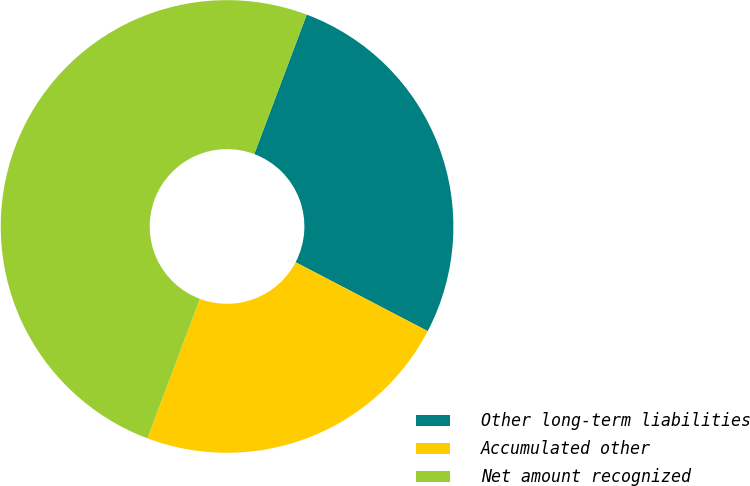<chart> <loc_0><loc_0><loc_500><loc_500><pie_chart><fcel>Other long-term liabilities<fcel>Accumulated other<fcel>Net amount recognized<nl><fcel>26.93%<fcel>23.07%<fcel>50.0%<nl></chart> 